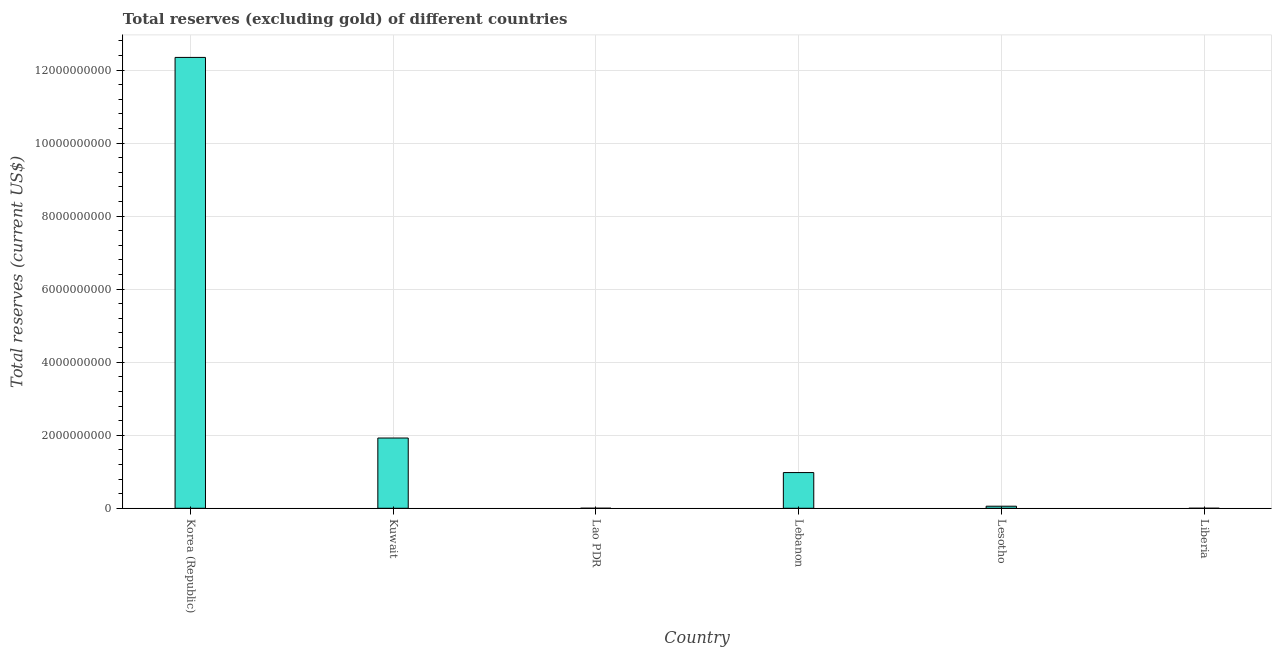Does the graph contain any zero values?
Keep it short and to the point. No. What is the title of the graph?
Your answer should be very brief. Total reserves (excluding gold) of different countries. What is the label or title of the Y-axis?
Give a very brief answer. Total reserves (current US$). What is the total reserves (excluding gold) in Lebanon?
Make the answer very short. 9.78e+08. Across all countries, what is the maximum total reserves (excluding gold)?
Provide a short and direct response. 1.23e+1. Across all countries, what is the minimum total reserves (excluding gold)?
Keep it short and to the point. 3.80e+05. In which country was the total reserves (excluding gold) maximum?
Provide a succinct answer. Korea (Republic). In which country was the total reserves (excluding gold) minimum?
Ensure brevity in your answer.  Liberia. What is the sum of the total reserves (excluding gold)?
Offer a terse response. 1.53e+1. What is the difference between the total reserves (excluding gold) in Korea (Republic) and Liberia?
Keep it short and to the point. 1.23e+1. What is the average total reserves (excluding gold) per country?
Your answer should be compact. 2.55e+09. What is the median total reserves (excluding gold)?
Provide a succinct answer. 5.17e+08. What is the ratio of the total reserves (excluding gold) in Korea (Republic) to that in Lao PDR?
Offer a very short reply. 1.93e+04. What is the difference between the highest and the second highest total reserves (excluding gold)?
Give a very brief answer. 1.04e+1. What is the difference between the highest and the lowest total reserves (excluding gold)?
Your answer should be very brief. 1.23e+1. What is the difference between two consecutive major ticks on the Y-axis?
Your answer should be very brief. 2.00e+09. Are the values on the major ticks of Y-axis written in scientific E-notation?
Provide a succinct answer. No. What is the Total reserves (current US$) of Korea (Republic)?
Offer a very short reply. 1.23e+1. What is the Total reserves (current US$) of Kuwait?
Provide a succinct answer. 1.92e+09. What is the Total reserves (current US$) in Lao PDR?
Keep it short and to the point. 6.41e+05. What is the Total reserves (current US$) of Lebanon?
Your answer should be very brief. 9.78e+08. What is the Total reserves (current US$) in Lesotho?
Offer a terse response. 5.63e+07. What is the Total reserves (current US$) of Liberia?
Make the answer very short. 3.80e+05. What is the difference between the Total reserves (current US$) in Korea (Republic) and Kuwait?
Ensure brevity in your answer.  1.04e+1. What is the difference between the Total reserves (current US$) in Korea (Republic) and Lao PDR?
Make the answer very short. 1.23e+1. What is the difference between the Total reserves (current US$) in Korea (Republic) and Lebanon?
Provide a short and direct response. 1.14e+1. What is the difference between the Total reserves (current US$) in Korea (Republic) and Lesotho?
Provide a short and direct response. 1.23e+1. What is the difference between the Total reserves (current US$) in Korea (Republic) and Liberia?
Offer a terse response. 1.23e+1. What is the difference between the Total reserves (current US$) in Kuwait and Lao PDR?
Your response must be concise. 1.92e+09. What is the difference between the Total reserves (current US$) in Kuwait and Lebanon?
Offer a very short reply. 9.46e+08. What is the difference between the Total reserves (current US$) in Kuwait and Lesotho?
Your answer should be very brief. 1.87e+09. What is the difference between the Total reserves (current US$) in Kuwait and Liberia?
Provide a short and direct response. 1.92e+09. What is the difference between the Total reserves (current US$) in Lao PDR and Lebanon?
Keep it short and to the point. -9.77e+08. What is the difference between the Total reserves (current US$) in Lao PDR and Lesotho?
Make the answer very short. -5.56e+07. What is the difference between the Total reserves (current US$) in Lao PDR and Liberia?
Offer a terse response. 2.61e+05. What is the difference between the Total reserves (current US$) in Lebanon and Lesotho?
Offer a terse response. 9.22e+08. What is the difference between the Total reserves (current US$) in Lebanon and Liberia?
Your answer should be very brief. 9.77e+08. What is the difference between the Total reserves (current US$) in Lesotho and Liberia?
Ensure brevity in your answer.  5.59e+07. What is the ratio of the Total reserves (current US$) in Korea (Republic) to that in Kuwait?
Your answer should be compact. 6.42. What is the ratio of the Total reserves (current US$) in Korea (Republic) to that in Lao PDR?
Your response must be concise. 1.93e+04. What is the ratio of the Total reserves (current US$) in Korea (Republic) to that in Lebanon?
Give a very brief answer. 12.63. What is the ratio of the Total reserves (current US$) in Korea (Republic) to that in Lesotho?
Provide a short and direct response. 219.38. What is the ratio of the Total reserves (current US$) in Korea (Republic) to that in Liberia?
Make the answer very short. 3.25e+04. What is the ratio of the Total reserves (current US$) in Kuwait to that in Lao PDR?
Your answer should be very brief. 3001.39. What is the ratio of the Total reserves (current US$) in Kuwait to that in Lebanon?
Provide a succinct answer. 1.97. What is the ratio of the Total reserves (current US$) in Kuwait to that in Lesotho?
Make the answer very short. 34.18. What is the ratio of the Total reserves (current US$) in Kuwait to that in Liberia?
Give a very brief answer. 5057.01. What is the ratio of the Total reserves (current US$) in Lao PDR to that in Lebanon?
Ensure brevity in your answer.  0. What is the ratio of the Total reserves (current US$) in Lao PDR to that in Lesotho?
Provide a succinct answer. 0.01. What is the ratio of the Total reserves (current US$) in Lao PDR to that in Liberia?
Provide a succinct answer. 1.69. What is the ratio of the Total reserves (current US$) in Lebanon to that in Lesotho?
Your response must be concise. 17.37. What is the ratio of the Total reserves (current US$) in Lebanon to that in Liberia?
Give a very brief answer. 2570.7. What is the ratio of the Total reserves (current US$) in Lesotho to that in Liberia?
Your answer should be compact. 147.96. 